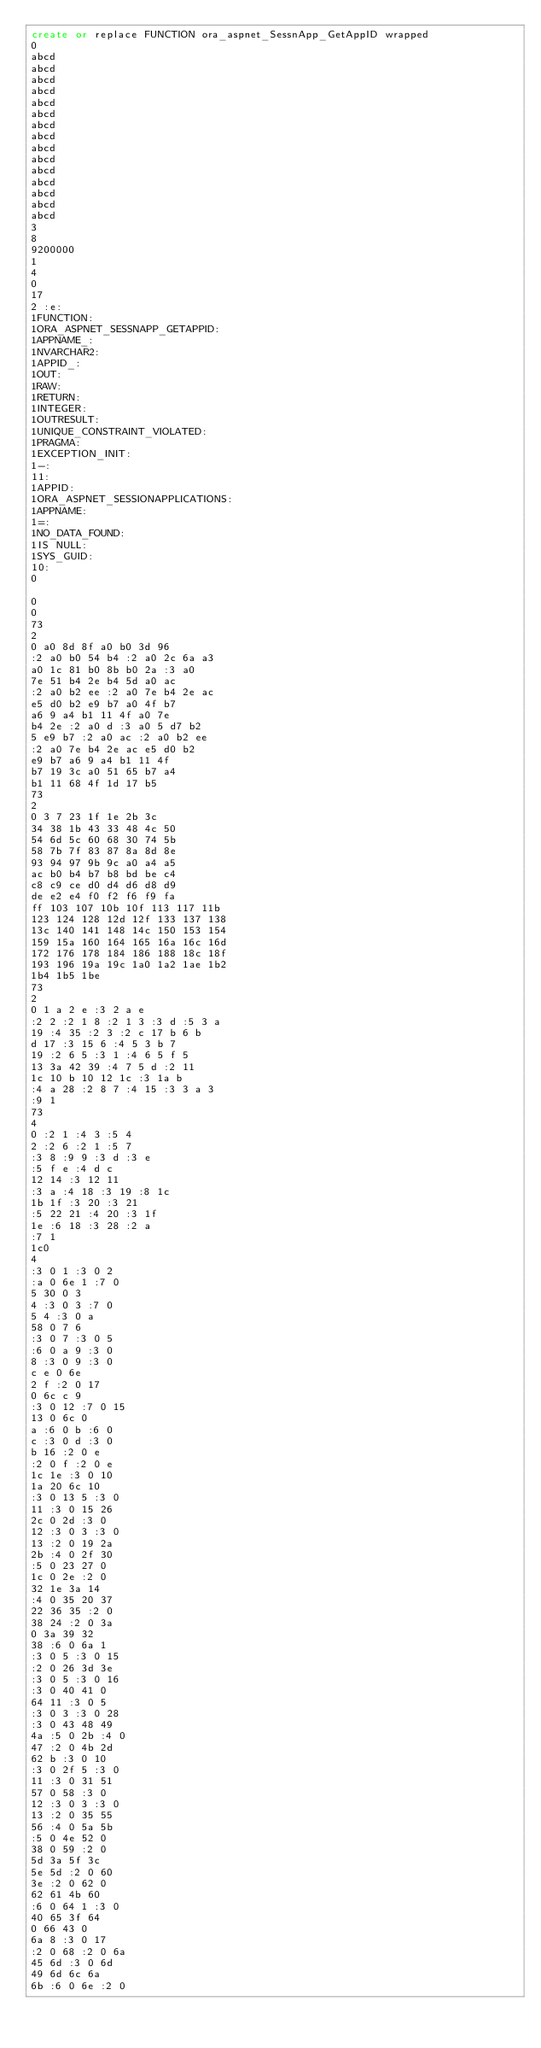Convert code to text. <code><loc_0><loc_0><loc_500><loc_500><_SQL_>create or replace FUNCTION ora_aspnet_SessnApp_GetAppID wrapped 
0
abcd
abcd
abcd
abcd
abcd
abcd
abcd
abcd
abcd
abcd
abcd
abcd
abcd
abcd
abcd
3
8
9200000
1
4
0 
17
2 :e:
1FUNCTION:
1ORA_ASPNET_SESSNAPP_GETAPPID:
1APPNAME_:
1NVARCHAR2:
1APPID_:
1OUT:
1RAW:
1RETURN:
1INTEGER:
1OUTRESULT:
1UNIQUE_CONSTRAINT_VIOLATED:
1PRAGMA:
1EXCEPTION_INIT:
1-:
11:
1APPID:
1ORA_ASPNET_SESSIONAPPLICATIONS:
1APPNAME:
1=:
1NO_DATA_FOUND:
1IS NULL:
1SYS_GUID:
10:
0

0
0
73
2
0 a0 8d 8f a0 b0 3d 96
:2 a0 b0 54 b4 :2 a0 2c 6a a3
a0 1c 81 b0 8b b0 2a :3 a0
7e 51 b4 2e b4 5d a0 ac
:2 a0 b2 ee :2 a0 7e b4 2e ac
e5 d0 b2 e9 b7 a0 4f b7
a6 9 a4 b1 11 4f a0 7e
b4 2e :2 a0 d :3 a0 5 d7 b2
5 e9 b7 :2 a0 ac :2 a0 b2 ee
:2 a0 7e b4 2e ac e5 d0 b2
e9 b7 a6 9 a4 b1 11 4f
b7 19 3c a0 51 65 b7 a4
b1 11 68 4f 1d 17 b5 
73
2
0 3 7 23 1f 1e 2b 3c
34 38 1b 43 33 48 4c 50
54 6d 5c 60 68 30 74 5b
58 7b 7f 83 87 8a 8d 8e
93 94 97 9b 9c a0 a4 a5
ac b0 b4 b7 b8 bd be c4
c8 c9 ce d0 d4 d6 d8 d9
de e2 e4 f0 f2 f6 f9 fa
ff 103 107 10b 10f 113 117 11b
123 124 128 12d 12f 133 137 138
13c 140 141 148 14c 150 153 154
159 15a 160 164 165 16a 16c 16d
172 176 178 184 186 188 18c 18f
193 196 19a 19c 1a0 1a2 1ae 1b2
1b4 1b5 1be 
73
2
0 1 a 2 e :3 2 a e
:2 2 :2 1 8 :2 1 3 :3 d :5 3 a
19 :4 35 :2 3 :2 c 17 b 6 b
d 17 :3 15 6 :4 5 3 b 7
19 :2 6 5 :3 1 :4 6 5 f 5
13 3a 42 39 :4 7 5 d :2 11
1c 10 b 10 12 1c :3 1a b
:4 a 28 :2 8 7 :4 15 :3 3 a 3
:9 1 
73
4
0 :2 1 :4 3 :5 4
2 :2 6 :2 1 :5 7
:3 8 :9 9 :3 d :3 e
:5 f e :4 d c
12 14 :3 12 11
:3 a :4 18 :3 19 :8 1c
1b 1f :3 20 :3 21
:5 22 21 :4 20 :3 1f
1e :6 18 :3 28 :2 a
:7 1 
1c0
4
:3 0 1 :3 0 2
:a 0 6e 1 :7 0
5 30 0 3
4 :3 0 3 :7 0
5 4 :3 0 a
58 0 7 6
:3 0 7 :3 0 5
:6 0 a 9 :3 0
8 :3 0 9 :3 0
c e 0 6e
2 f :2 0 17
0 6c c 9
:3 0 12 :7 0 15
13 0 6c 0
a :6 0 b :6 0
c :3 0 d :3 0
b 16 :2 0 e
:2 0 f :2 0 e
1c 1e :3 0 10
1a 20 6c 10
:3 0 13 5 :3 0
11 :3 0 15 26
2c 0 2d :3 0
12 :3 0 3 :3 0
13 :2 0 19 2a
2b :4 0 2f 30
:5 0 23 27 0
1c 0 2e :2 0
32 1e 3a 14
:4 0 35 20 37
22 36 35 :2 0
38 24 :2 0 3a
0 3a 39 32
38 :6 0 6a 1
:3 0 5 :3 0 15
:2 0 26 3d 3e
:3 0 5 :3 0 16
:3 0 40 41 0
64 11 :3 0 5
:3 0 3 :3 0 28
:3 0 43 48 49
4a :5 0 2b :4 0
47 :2 0 4b 2d
62 b :3 0 10
:3 0 2f 5 :3 0
11 :3 0 31 51
57 0 58 :3 0
12 :3 0 3 :3 0
13 :2 0 35 55
56 :4 0 5a 5b
:5 0 4e 52 0
38 0 59 :2 0
5d 3a 5f 3c
5e 5d :2 0 60
3e :2 0 62 0
62 61 4b 60
:6 0 64 1 :3 0
40 65 3f 64
0 66 43 0
6a 8 :3 0 17
:2 0 68 :2 0 6a
45 6d :3 0 6d
49 6d 6c 6a
6b :6 0 6e :2 0</code> 